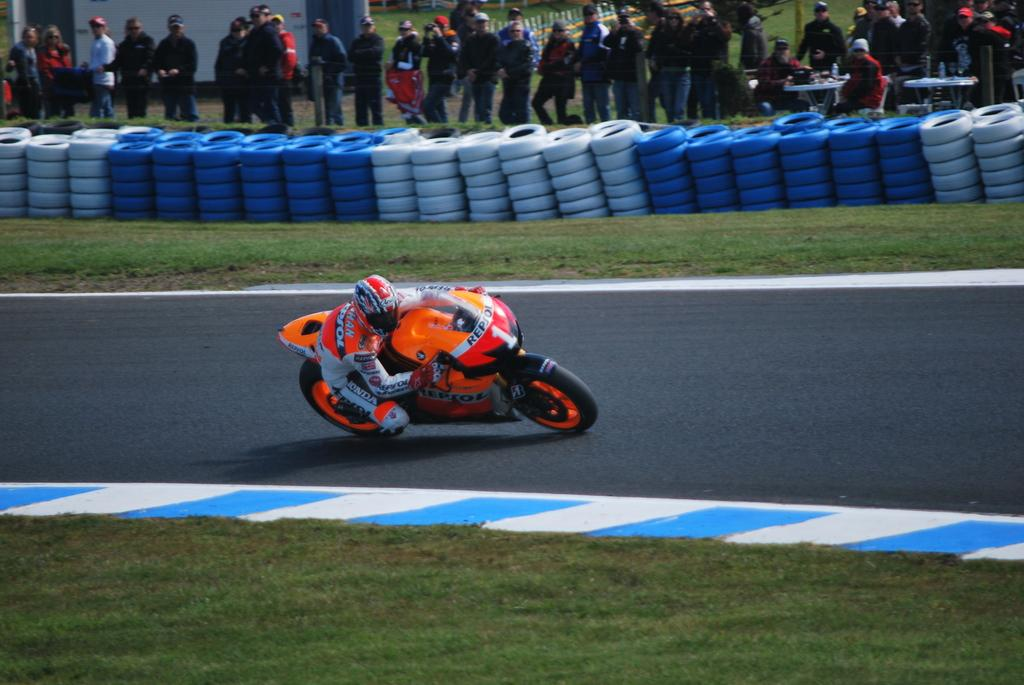What is the main subject of the image? There is a person riding a bike in the image. Can you describe the people in the image? There are people in the image, but the focus is on the person riding the bike. What objects can be seen on the tables in the image? The tables have objects on them, but the specific objects are not mentioned in the facts. What type of surface is visible in the image? There are tires visible in the image, which suggests that there is a paved or hard surface. What type of vegetation is present in the image? There is grass in the image. What structures can be seen in the image? There is a fence and a wall in the image. What type of plant is being used to lead the group of people in the image? There is no plant present in the image, nor is there any indication of a group of people being led. 